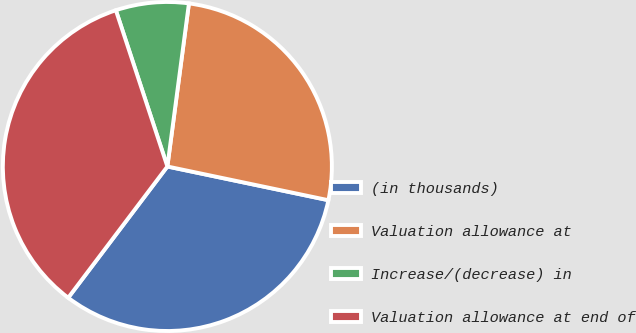Convert chart to OTSL. <chart><loc_0><loc_0><loc_500><loc_500><pie_chart><fcel>(in thousands)<fcel>Valuation allowance at<fcel>Increase/(decrease) in<fcel>Valuation allowance at end of<nl><fcel>32.01%<fcel>26.19%<fcel>7.16%<fcel>34.63%<nl></chart> 